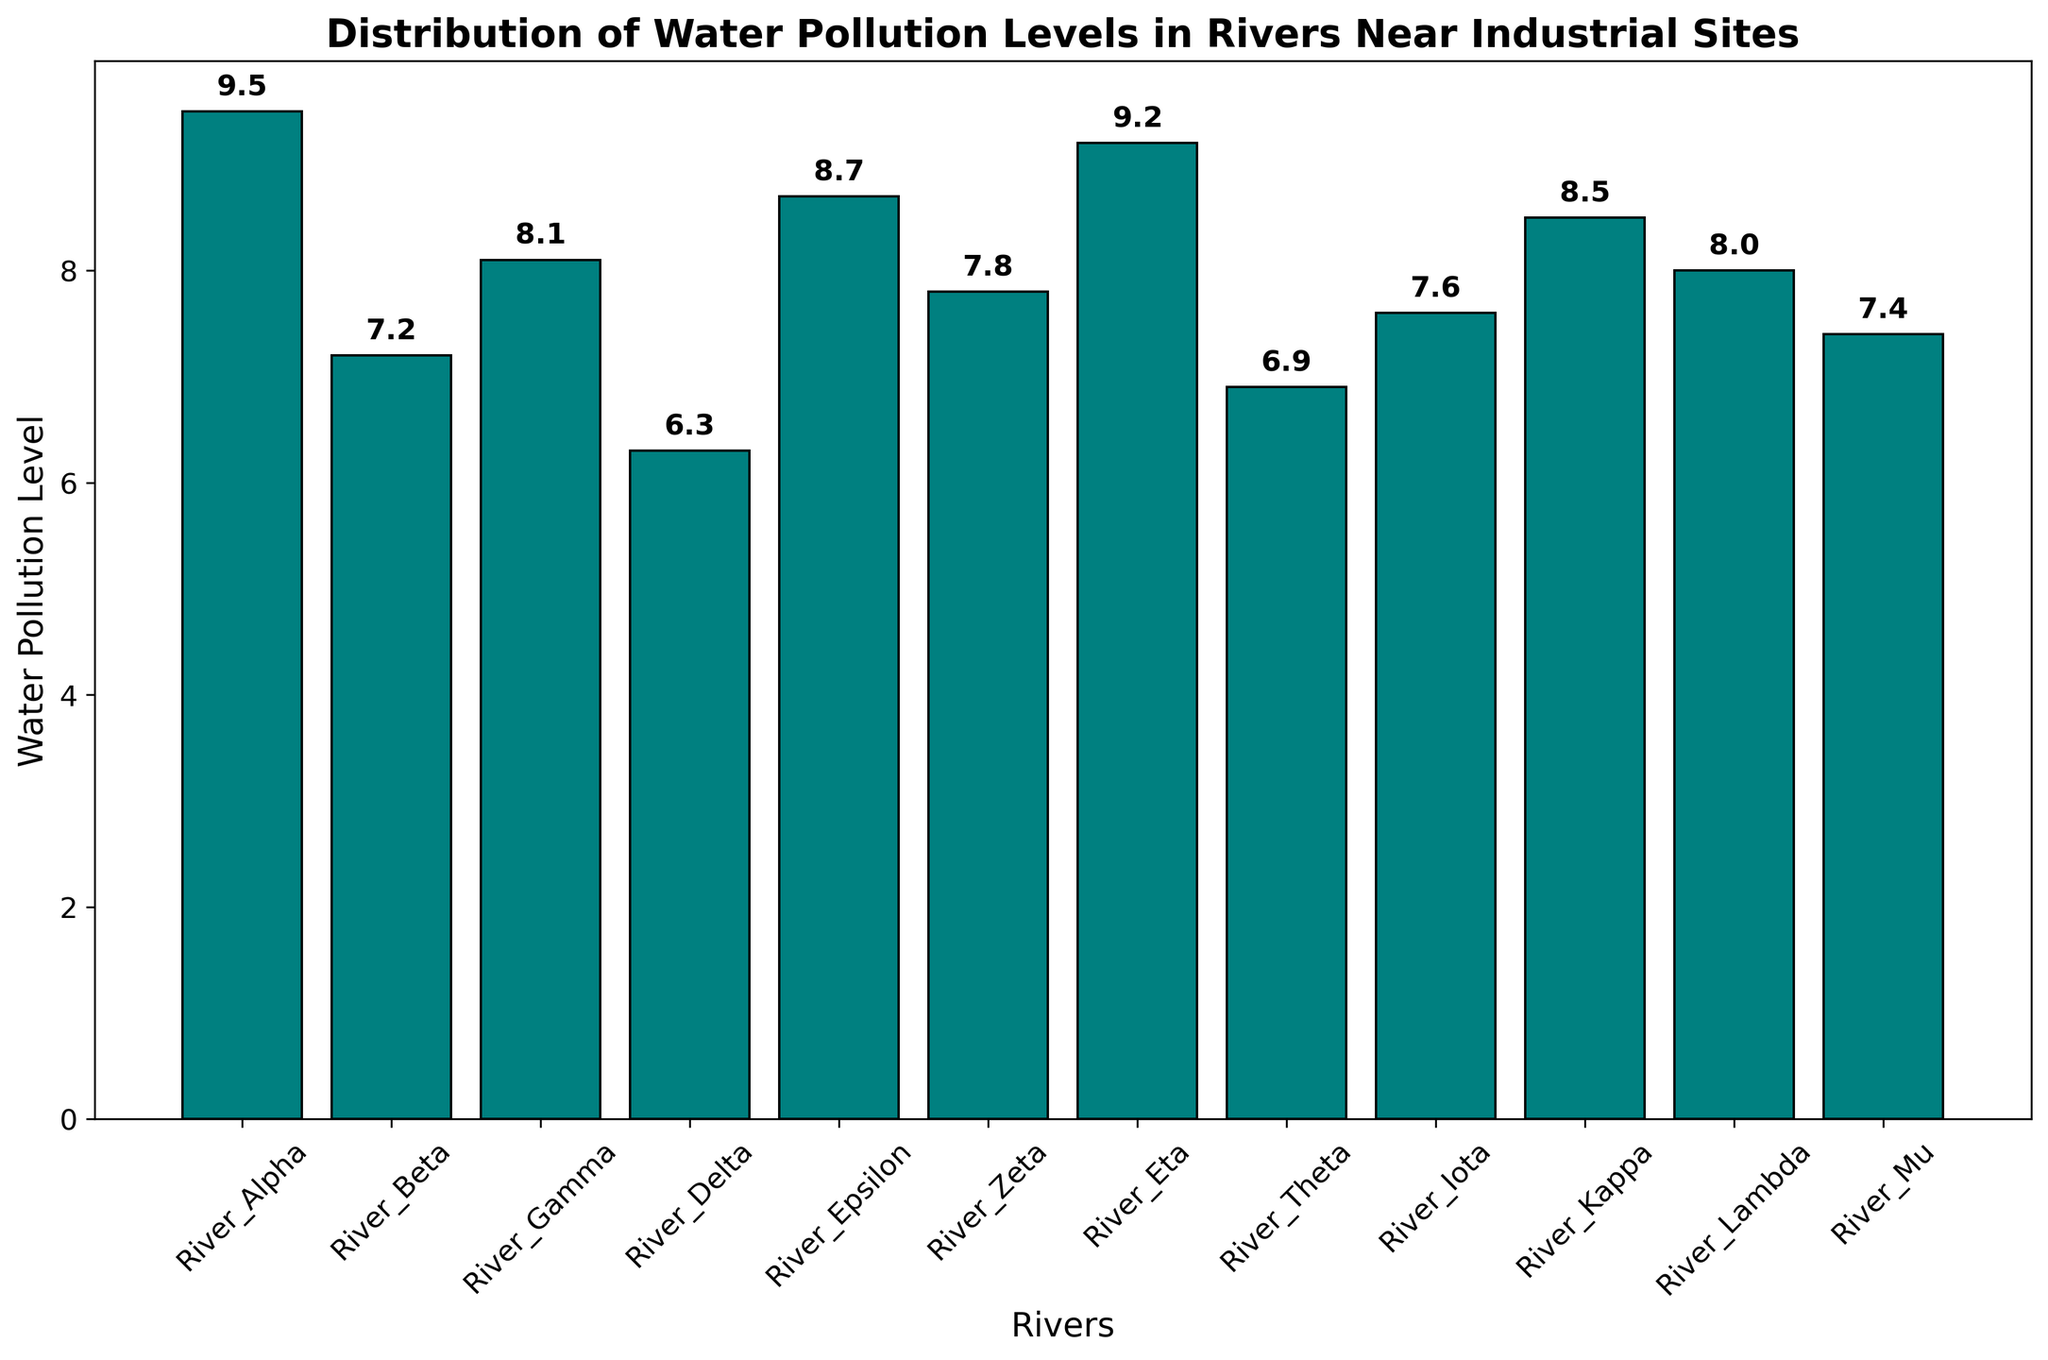Which river has the highest water pollution level? By visually inspecting the heights of the bars, we see that River Alpha has the tallest bar.
Answer: River Alpha Which river has the lowest water pollution level? By visually inspecting the heights of the bars, we see that River Delta has the shortest bar.
Answer: River Delta What is the average water pollution level across all rivers? Add all pollution levels: 9.5 + 7.2 + 8.1 + 6.3 + 8.7 + 7.8 + 9.2 + 6.9 + 7.6 + 8.5 + 8.0 + 7.4 = 95.2. Divide by the number of rivers (12).
Answer: 7.93 How many rivers have a pollution level greater than 8.0? Count the bars with heights indicating levels greater than 8.0: Alpha, Gamma, Epsilon, Eta, Kappa, Lambda.
Answer: 6 Which two rivers have the water pollution levels closest to each other? By comparing the heights of the bars, River Lambda (8.0) and River Gamma (8.1) are closest.
Answer: Lambda and Gamma What is the total water pollution level for rivers with values less than 7.0? Add pollution levels of rivers Delta (6.3) and Theta (6.9): 6.3 + 6.9 = 13.2.
Answer: 13.2 How much higher is the water pollution level of River Alpha compared to River Delta? Subtract the pollution levels: 9.5 - 6.3 = 3.2.
Answer: 3.2 Which river's pollution level is exactly 7.4? By looking at the bars, River Mu has a pollution level of 7.4.
Answer: River Mu What is the median water pollution level for all rivers? Order the levels: 6.3, 6.9, 7.2, 7.4, 7.6, 7.8, 8.0, 8.1, 8.5, 8.7, 9.2, 9.5. The middle values are 7.8 and 8.0, so the median is (7.8 + 8.0)/2 = 7.9.
Answer: 7.9 